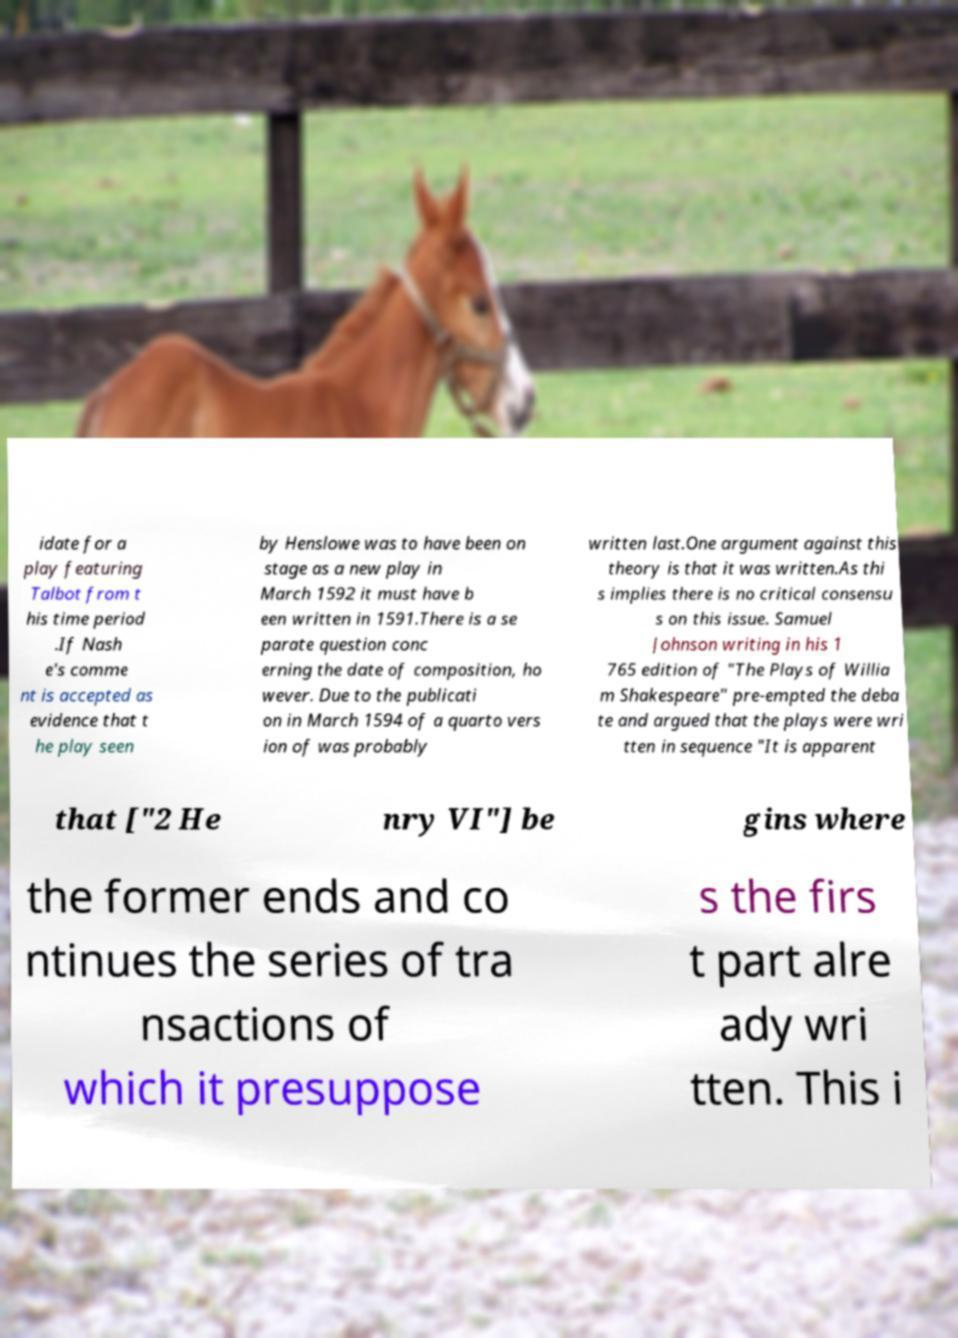Please read and relay the text visible in this image. What does it say? idate for a play featuring Talbot from t his time period .If Nash e's comme nt is accepted as evidence that t he play seen by Henslowe was to have been on stage as a new play in March 1592 it must have b een written in 1591.There is a se parate question conc erning the date of composition, ho wever. Due to the publicati on in March 1594 of a quarto vers ion of was probably written last.One argument against this theory is that it was written.As thi s implies there is no critical consensu s on this issue. Samuel Johnson writing in his 1 765 edition of "The Plays of Willia m Shakespeare" pre-empted the deba te and argued that the plays were wri tten in sequence "It is apparent that ["2 He nry VI"] be gins where the former ends and co ntinues the series of tra nsactions of which it presuppose s the firs t part alre ady wri tten. This i 